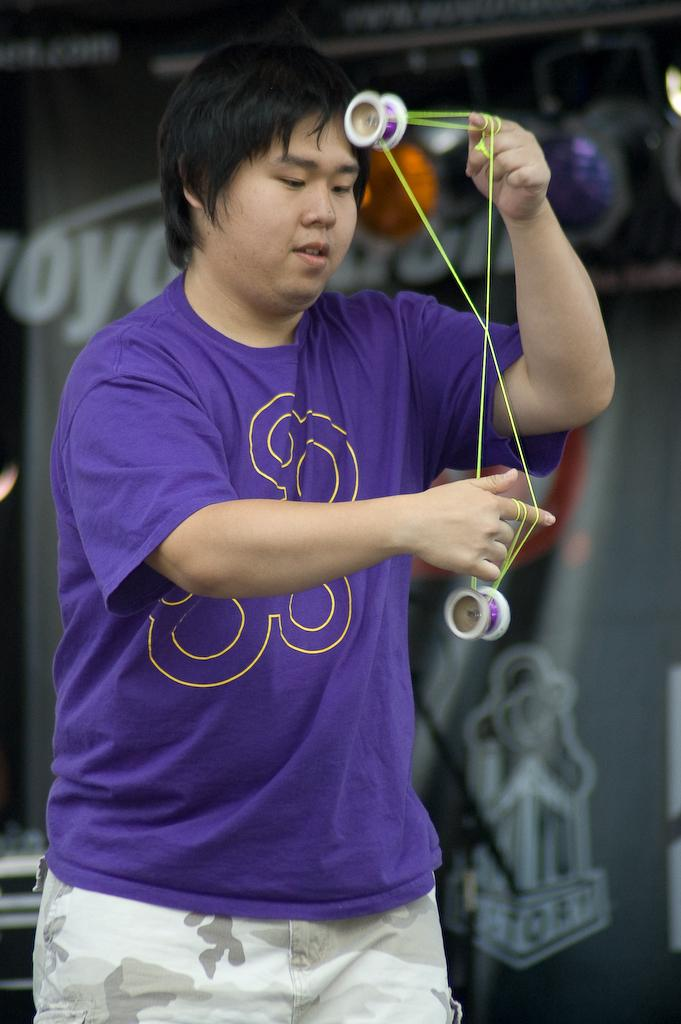Who is present in the image? There is a person in the image. What is the person wearing? The person is wearing a blue t-shirt. What is the person holding in the image? The person is holding a thread. What can be seen in the background of the image? There is a building in the background of the image. What type of plants can be seen growing in the bubble in the image? There is no bubble present in the image, and therefore no plants growing in it. 